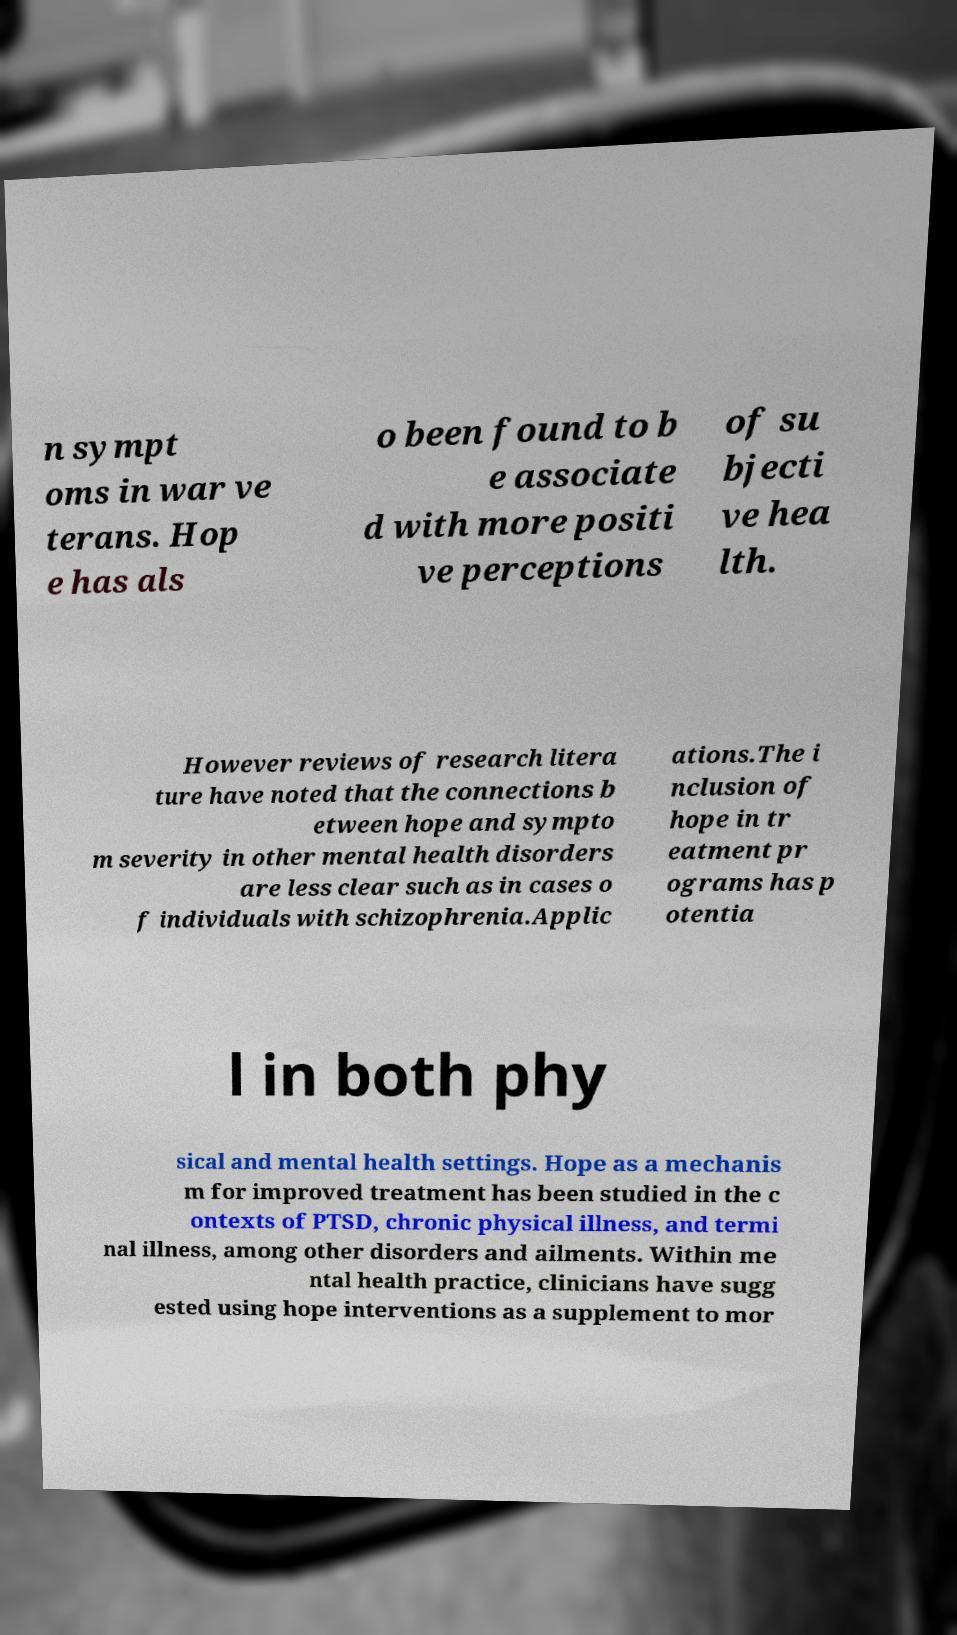There's text embedded in this image that I need extracted. Can you transcribe it verbatim? n sympt oms in war ve terans. Hop e has als o been found to b e associate d with more positi ve perceptions of su bjecti ve hea lth. However reviews of research litera ture have noted that the connections b etween hope and sympto m severity in other mental health disorders are less clear such as in cases o f individuals with schizophrenia.Applic ations.The i nclusion of hope in tr eatment pr ograms has p otentia l in both phy sical and mental health settings. Hope as a mechanis m for improved treatment has been studied in the c ontexts of PTSD, chronic physical illness, and termi nal illness, among other disorders and ailments. Within me ntal health practice, clinicians have sugg ested using hope interventions as a supplement to mor 